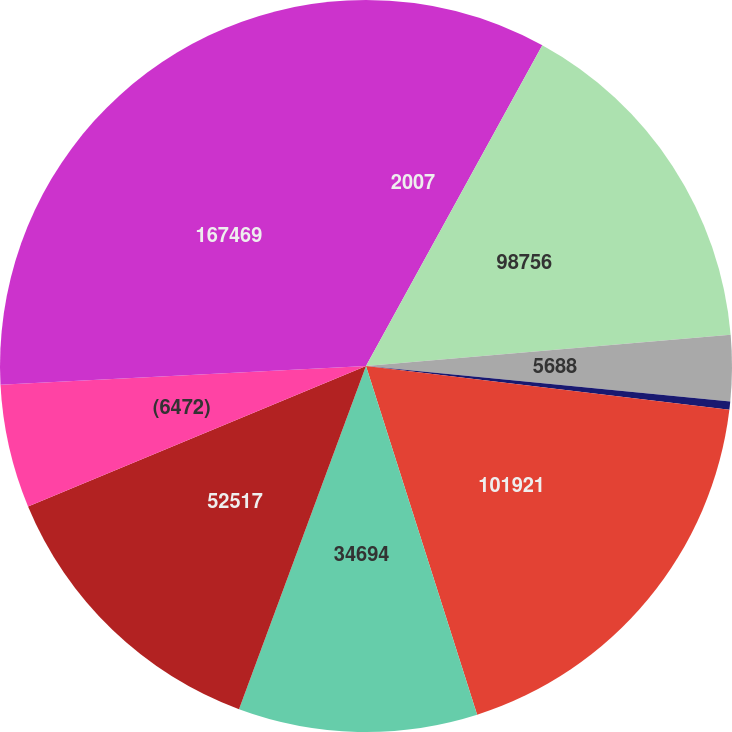Convert chart. <chart><loc_0><loc_0><loc_500><loc_500><pie_chart><fcel>2007<fcel>98756<fcel>5688<fcel>(2523)<fcel>101921<fcel>34694<fcel>52517<fcel>(6472)<fcel>167469<nl><fcel>8.0%<fcel>15.64%<fcel>2.91%<fcel>0.36%<fcel>18.18%<fcel>10.55%<fcel>13.09%<fcel>5.45%<fcel>25.82%<nl></chart> 